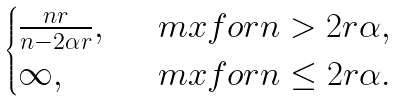Convert formula to latex. <formula><loc_0><loc_0><loc_500><loc_500>\begin{cases} \frac { n r } { n - 2 \alpha r } , \ & \ m x { f o r } n > 2 r \alpha , \\ \infty , \ & \ m x { f o r } n \leq 2 r \alpha . \end{cases}</formula> 